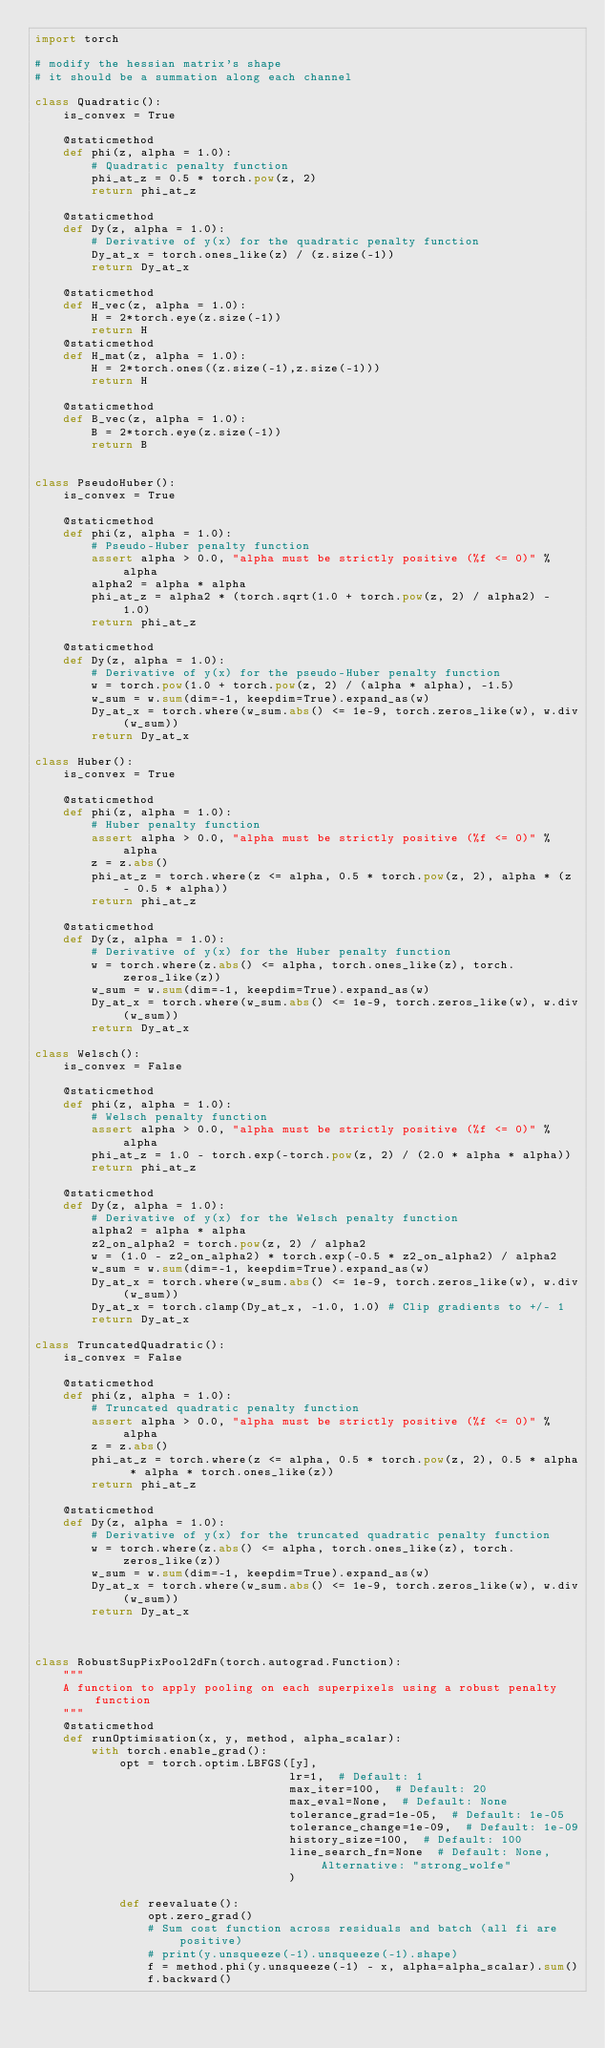<code> <loc_0><loc_0><loc_500><loc_500><_Python_>import torch

# modify the hessian matrix's shape
# it should be a summation along each channel

class Quadratic():
    is_convex = True

    @staticmethod
    def phi(z, alpha = 1.0):
        # Quadratic penalty function
        phi_at_z = 0.5 * torch.pow(z, 2)
        return phi_at_z

    @staticmethod
    def Dy(z, alpha = 1.0):
        # Derivative of y(x) for the quadratic penalty function
        Dy_at_x = torch.ones_like(z) / (z.size(-1))
        return Dy_at_x

    @staticmethod
    def H_vec(z, alpha = 1.0):
        H = 2*torch.eye(z.size(-1))
        return H
    @staticmethod
    def H_mat(z, alpha = 1.0):
        H = 2*torch.ones((z.size(-1),z.size(-1)))
        return H

    @staticmethod
    def B_vec(z, alpha = 1.0):
        B = 2*torch.eye(z.size(-1))
        return B


class PseudoHuber():
    is_convex = True

    @staticmethod
    def phi(z, alpha = 1.0):
        # Pseudo-Huber penalty function
        assert alpha > 0.0, "alpha must be strictly positive (%f <= 0)" % alpha
        alpha2 = alpha * alpha
        phi_at_z = alpha2 * (torch.sqrt(1.0 + torch.pow(z, 2) / alpha2) - 1.0)
        return phi_at_z

    @staticmethod
    def Dy(z, alpha = 1.0):
        # Derivative of y(x) for the pseudo-Huber penalty function
        w = torch.pow(1.0 + torch.pow(z, 2) / (alpha * alpha), -1.5)
        w_sum = w.sum(dim=-1, keepdim=True).expand_as(w)
        Dy_at_x = torch.where(w_sum.abs() <= 1e-9, torch.zeros_like(w), w.div(w_sum))
        return Dy_at_x

class Huber():
    is_convex = True

    @staticmethod
    def phi(z, alpha = 1.0):
        # Huber penalty function
        assert alpha > 0.0, "alpha must be strictly positive (%f <= 0)" % alpha
        z = z.abs()
        phi_at_z = torch.where(z <= alpha, 0.5 * torch.pow(z, 2), alpha * (z - 0.5 * alpha))
        return phi_at_z

    @staticmethod
    def Dy(z, alpha = 1.0):
        # Derivative of y(x) for the Huber penalty function
        w = torch.where(z.abs() <= alpha, torch.ones_like(z), torch.zeros_like(z))
        w_sum = w.sum(dim=-1, keepdim=True).expand_as(w)
        Dy_at_x = torch.where(w_sum.abs() <= 1e-9, torch.zeros_like(w), w.div(w_sum))
        return Dy_at_x

class Welsch():
    is_convex = False

    @staticmethod
    def phi(z, alpha = 1.0):
        # Welsch penalty function
        assert alpha > 0.0, "alpha must be strictly positive (%f <= 0)" % alpha
        phi_at_z = 1.0 - torch.exp(-torch.pow(z, 2) / (2.0 * alpha * alpha))
        return phi_at_z

    @staticmethod
    def Dy(z, alpha = 1.0):
        # Derivative of y(x) for the Welsch penalty function
        alpha2 = alpha * alpha
        z2_on_alpha2 = torch.pow(z, 2) / alpha2
        w = (1.0 - z2_on_alpha2) * torch.exp(-0.5 * z2_on_alpha2) / alpha2
        w_sum = w.sum(dim=-1, keepdim=True).expand_as(w)
        Dy_at_x = torch.where(w_sum.abs() <= 1e-9, torch.zeros_like(w), w.div(w_sum))
        Dy_at_x = torch.clamp(Dy_at_x, -1.0, 1.0) # Clip gradients to +/- 1
        return Dy_at_x

class TruncatedQuadratic():
    is_convex = False

    @staticmethod
    def phi(z, alpha = 1.0):
        # Truncated quadratic penalty function
        assert alpha > 0.0, "alpha must be strictly positive (%f <= 0)" % alpha
        z = z.abs()
        phi_at_z = torch.where(z <= alpha, 0.5 * torch.pow(z, 2), 0.5 * alpha * alpha * torch.ones_like(z))
        return phi_at_z

    @staticmethod
    def Dy(z, alpha = 1.0):
        # Derivative of y(x) for the truncated quadratic penalty function
        w = torch.where(z.abs() <= alpha, torch.ones_like(z), torch.zeros_like(z))
        w_sum = w.sum(dim=-1, keepdim=True).expand_as(w)
        Dy_at_x = torch.where(w_sum.abs() <= 1e-9, torch.zeros_like(w), w.div(w_sum))
        return Dy_at_x



class RobustSupPixPool2dFn(torch.autograd.Function):
    """
    A function to apply pooling on each superpixels using a robust penalty function
    """
    @staticmethod
    def runOptimisation(x, y, method, alpha_scalar):
        with torch.enable_grad():
            opt = torch.optim.LBFGS([y],
                                    lr=1,  # Default: 1
                                    max_iter=100,  # Default: 20
                                    max_eval=None,  # Default: None
                                    tolerance_grad=1e-05,  # Default: 1e-05
                                    tolerance_change=1e-09,  # Default: 1e-09
                                    history_size=100,  # Default: 100
                                    line_search_fn=None  # Default: None, Alternative: "strong_wolfe"
                                    )

            def reevaluate():
                opt.zero_grad()
                # Sum cost function across residuals and batch (all fi are positive)
                # print(y.unsqueeze(-1).unsqueeze(-1).shape)
                f = method.phi(y.unsqueeze(-1) - x, alpha=alpha_scalar).sum()
                f.backward()</code> 